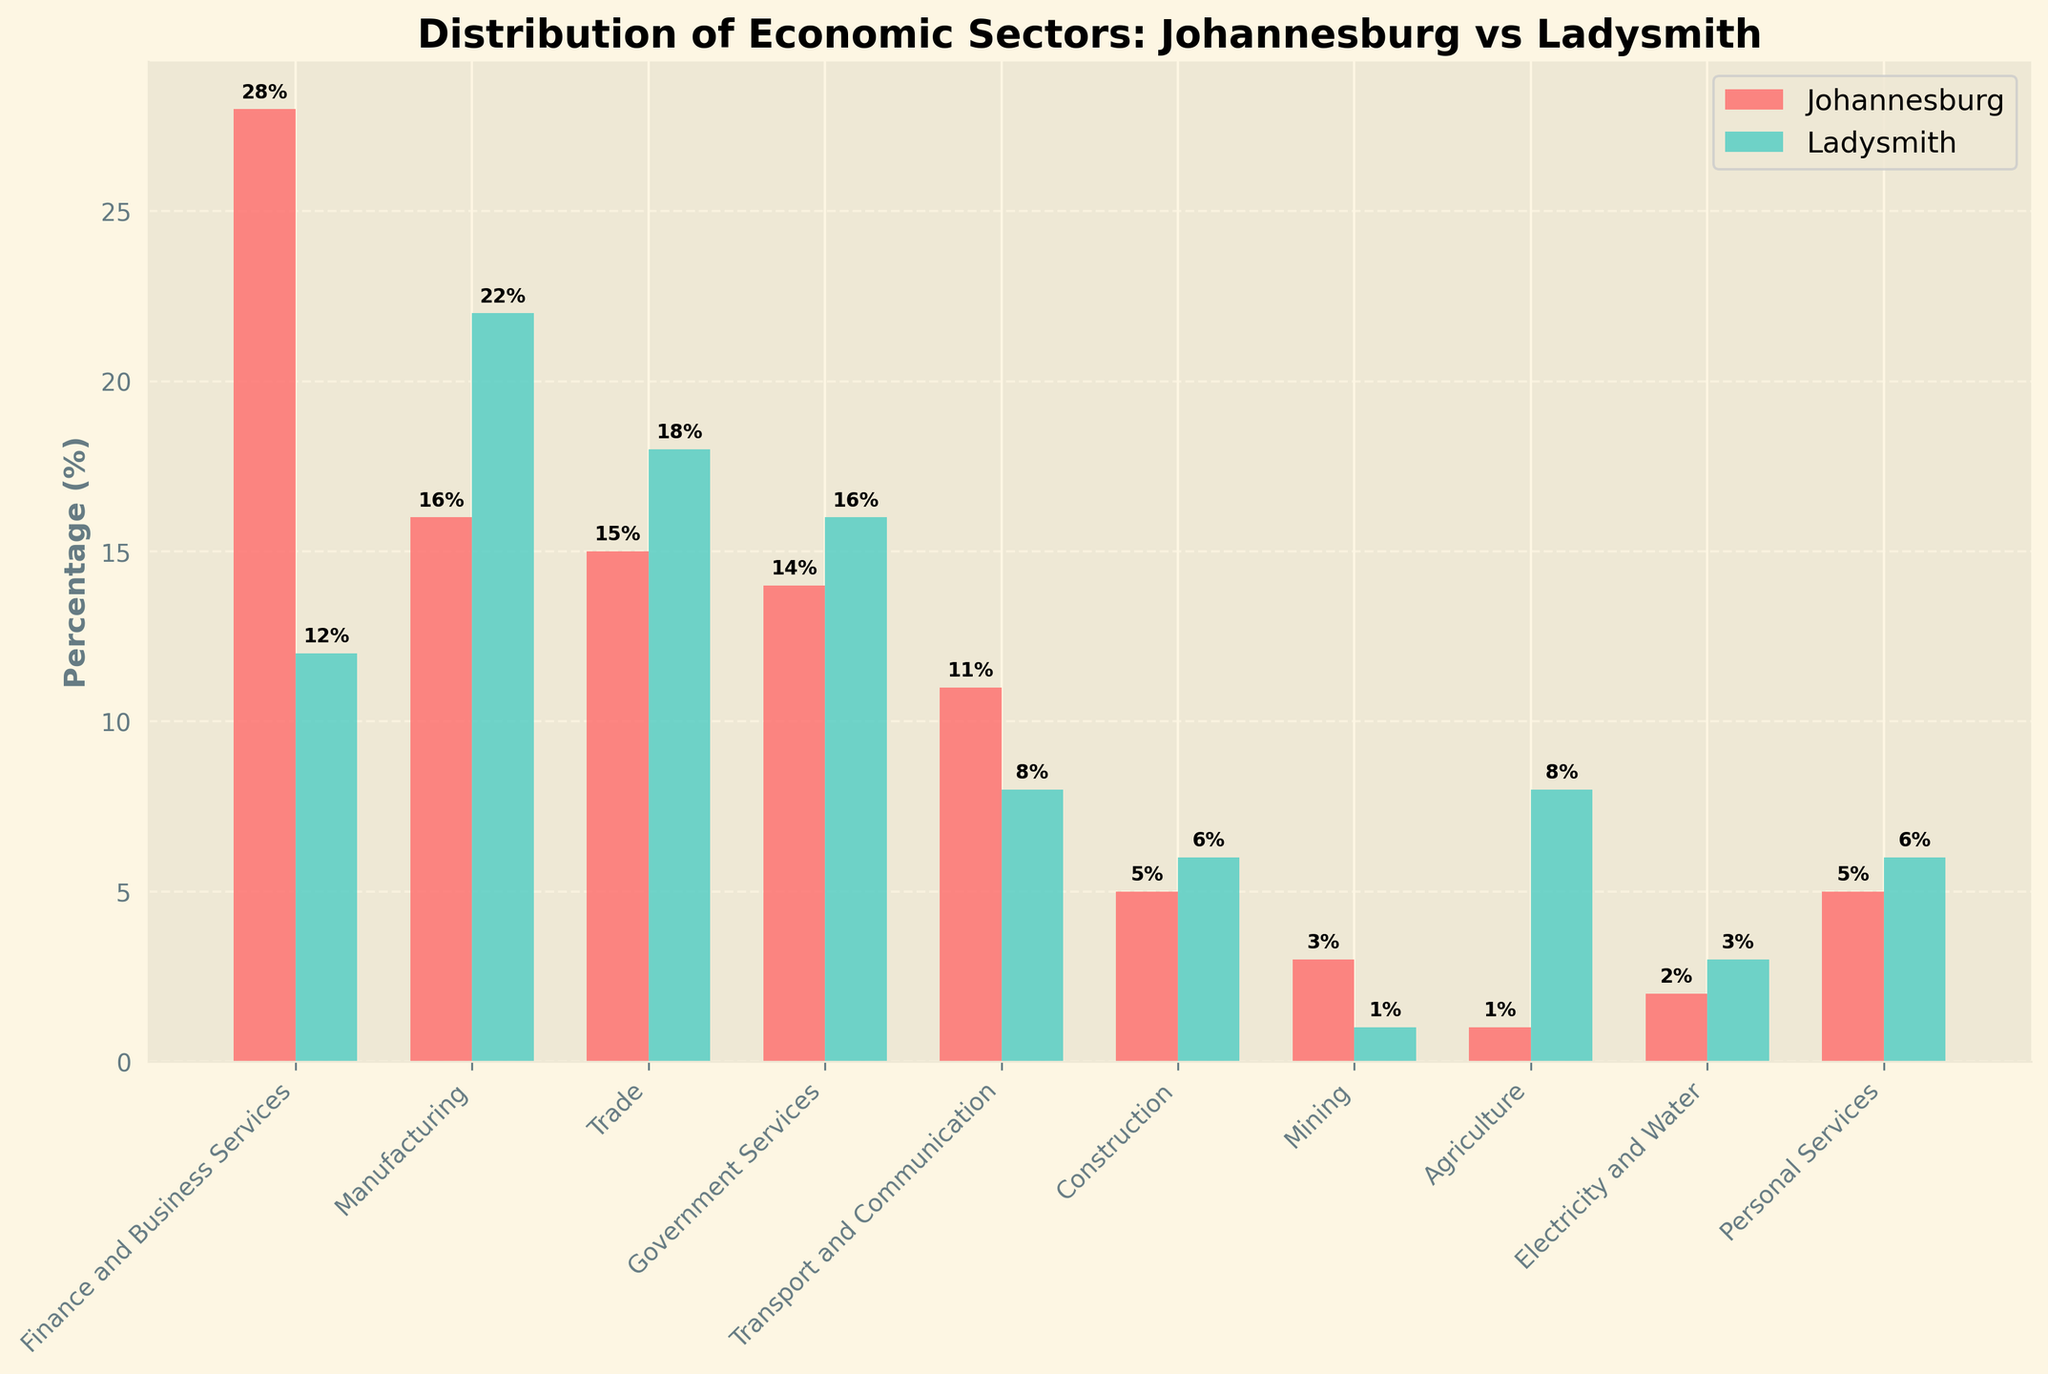What is the percentage difference in the Finance and Business Services sector between Johannesburg and Ladysmith? The percentage of Finance and Business Services in Johannesburg is 28%, while in Ladysmith it is 12%. The difference is calculated as 28% - 12% = 16%.
Answer: 16% Which sector has the highest percentage in Johannesburg, and what is its value? By looking at the heights of the bars, the Finance and Business Services sector has the highest percentage in Johannesburg at 28%.
Answer: Finance and Business Services, 28% Which sector shows the greatest difference in percentage points between Johannesburg and Ladysmith? Comparing the differences in percentage points for each sector, the Finance and Business Services sector has the greatest difference of 16 percentage points (28% in Johannesburg - 12% in Ladysmith).
Answer: Finance and Business Services Are there any sectors where Ladysmith has a higher percentage than Johannesburg? If yes, which ones and by how much? The sectors where Ladysmith has a higher percentage than Johannesburg are Manufacturing (22% in Ladysmith vs. 16% in Johannesburg, a difference of 6%), Trade (18% vs. 15%, a difference of 3%), Government Services (16% vs. 14%, a difference of 2%), Agriculture (8% vs. 1%, a difference of 7%), Construction (6% vs. 5%, a difference of 1%), and Electricity and Water (3% vs. 2%, a difference of 1%).
Answer: Manufacturing (6%), Trade (3%), Government Services (2%), Agriculture (7%), Construction (1%), Electricity and Water (1%) What is the combined percentage of Trade and Manufacturing sectors in Ladysmith? For the Trade sector, the percentage is 18%, and for Manufacturing, it is 22%. The combined percentage is 18% + 22% = 40%.
Answer: 40% Which sector has the least difference in percentage between Johannesburg and Ladysmith? The Construction sector has a small difference between Johannesburg (5%) and Ladysmith (6%), with a difference of just 1 percentage point.
Answer: Construction How does the percentage of the Mining sector in Johannesburg compare to that in Ladysmith? The Mining sector in Johannesburg has a percentage of 3%, while in Ladysmith it is 1%. Johannesburg's Mining sector is 2 percentage points higher than Ladysmith's.
Answer: Johannesburg's Mining sector is higher by 2% What is the average percentage of the Finance and Business Services, Manufacturing, and Trade sectors in Johannesburg? The percentages for Finance and Business Services, Manufacturing, and Trade sectors in Johannesburg are 28%, 16%, and 15%, respectively. The average is calculated as (28% + 16% + 15%) / 3 ≈ 19.67%.
Answer: 19.67% Which sectors have an equal distribution percentage in both Johannesburg and Ladysmith? By examining the bar chart, no sector has an equal percentage distribution in both Johannesburg and Ladysmith.
Answer: None What is the total percentage of Agriculture, Mining, and Transport and Communication sectors in Ladysmith? The percentages for Agriculture, Mining, and Transport and Communication sectors in Ladysmith are 8%, 1%, and 8%, respectively. The total is calculated as 8% + 1% + 8% = 17%.
Answer: 17% 